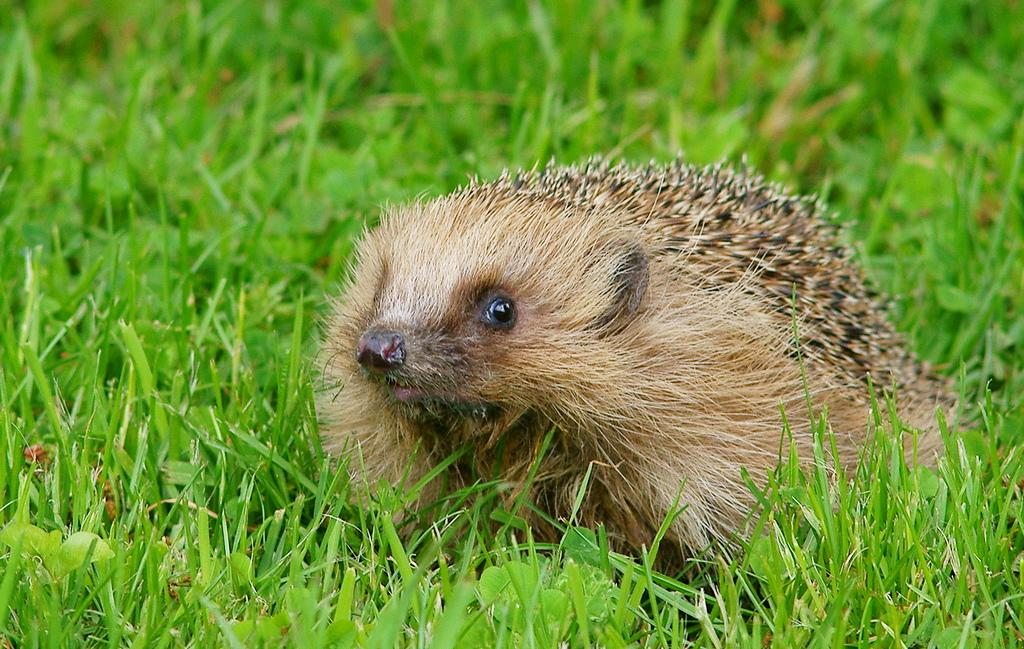What type of living creature is in the picture? There is an animal in the picture. Where is the animal located? The animal is on the grass. What color is the animal? The animal is light brown in color. What substance is the animal's sister using to paint the grass in the image? There is no mention of a substance or a sister in the image, and the animal is not shown painting the grass. 